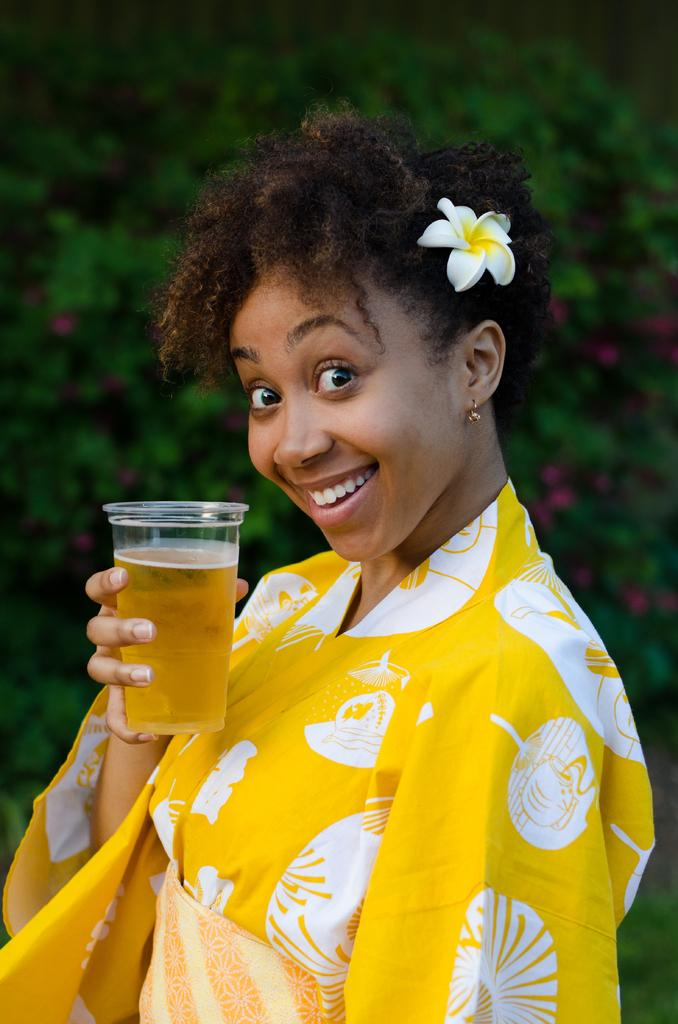Who is the main subject in the image? There is a lady in the center of the image. What is the lady doing in the image? The lady is standing and smiling. What is the lady holding in the image? The lady is holding a glass containing some liquid. What can be seen in the background of the image? There are trees and flowers in the background of the image. What historical event is being commemorated by the lady in the image? There is no indication of a historical event being commemorated in the image. The lady is simply standing and smiling while holding a glass. 